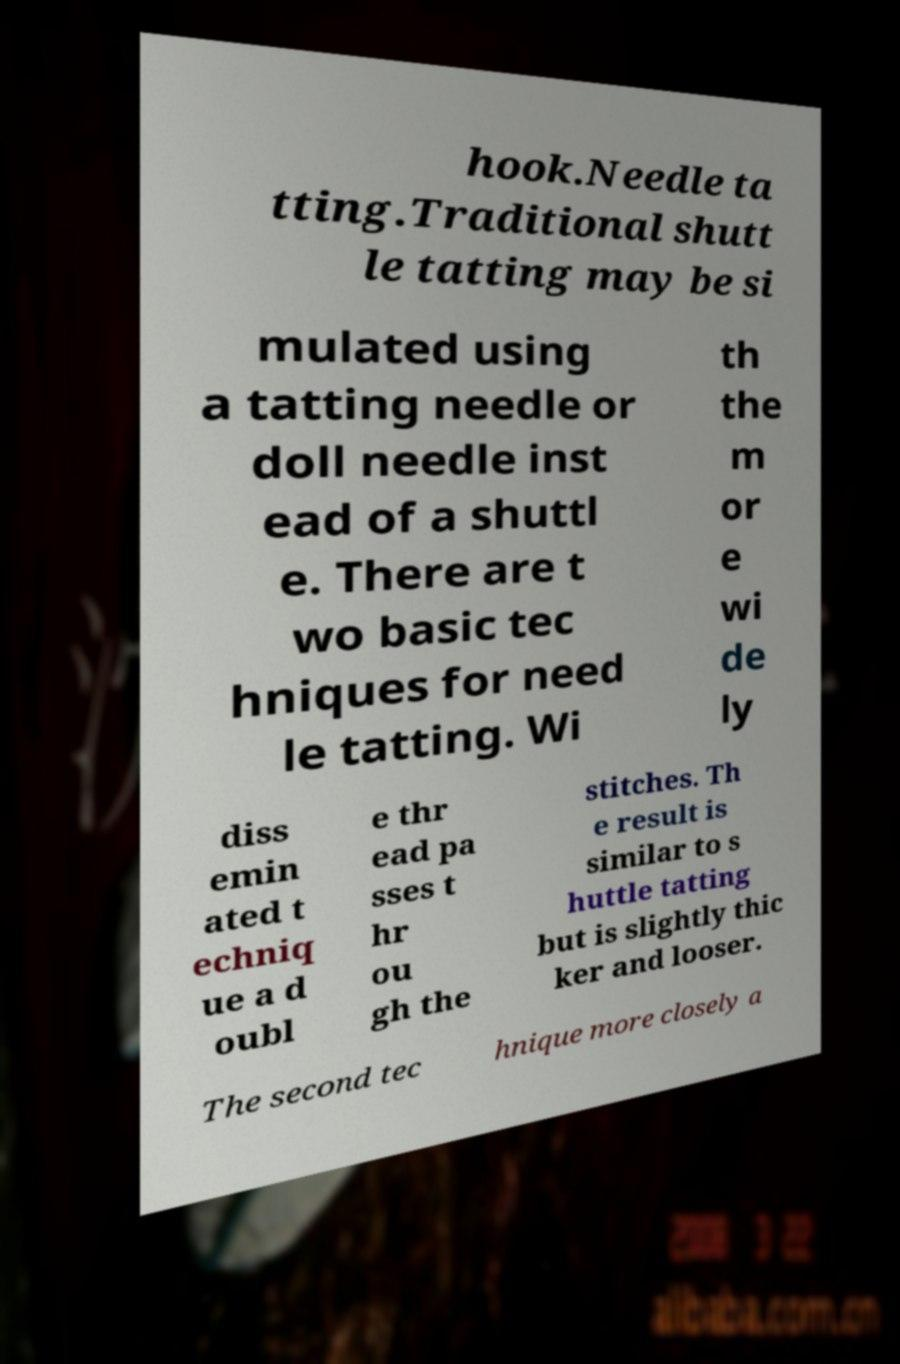Can you accurately transcribe the text from the provided image for me? hook.Needle ta tting.Traditional shutt le tatting may be si mulated using a tatting needle or doll needle inst ead of a shuttl e. There are t wo basic tec hniques for need le tatting. Wi th the m or e wi de ly diss emin ated t echniq ue a d oubl e thr ead pa sses t hr ou gh the stitches. Th e result is similar to s huttle tatting but is slightly thic ker and looser. The second tec hnique more closely a 